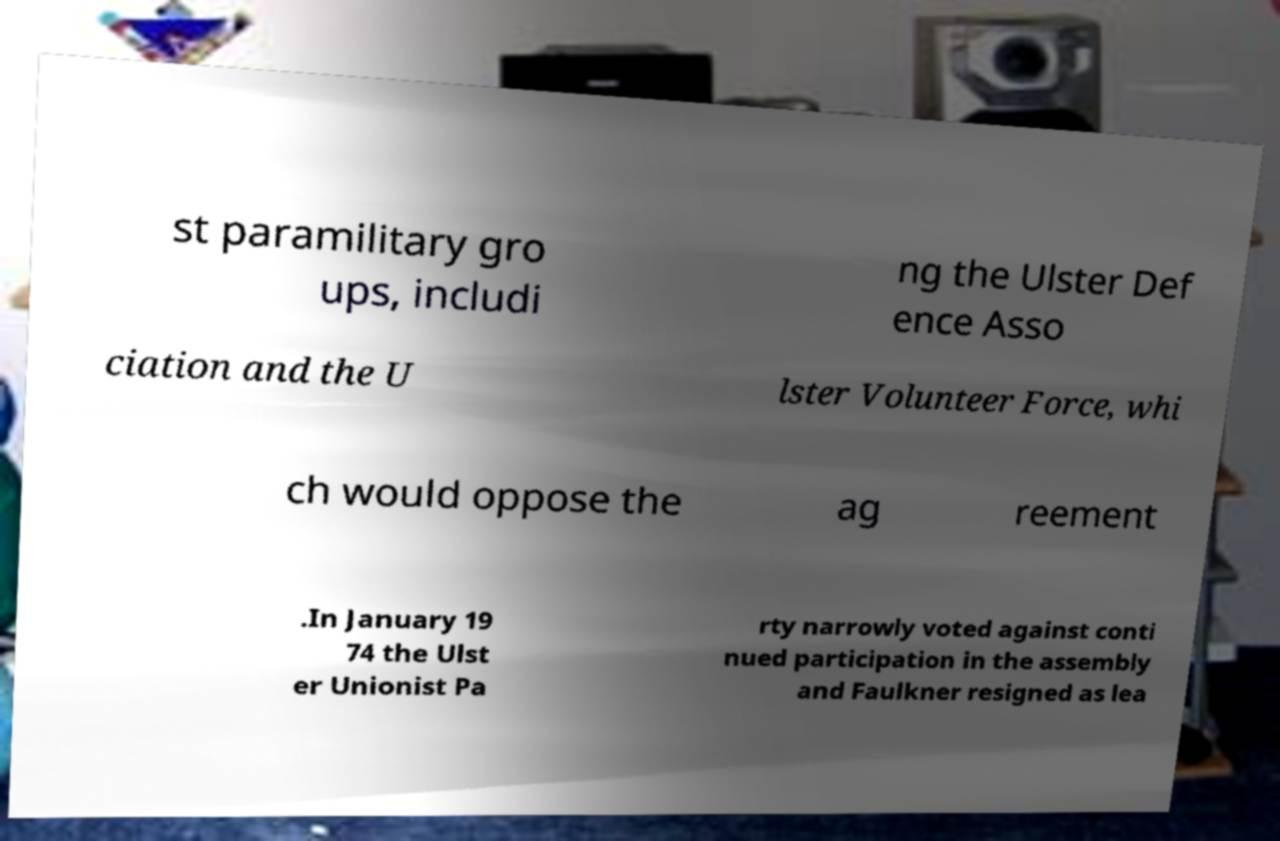Please identify and transcribe the text found in this image. st paramilitary gro ups, includi ng the Ulster Def ence Asso ciation and the U lster Volunteer Force, whi ch would oppose the ag reement .In January 19 74 the Ulst er Unionist Pa rty narrowly voted against conti nued participation in the assembly and Faulkner resigned as lea 